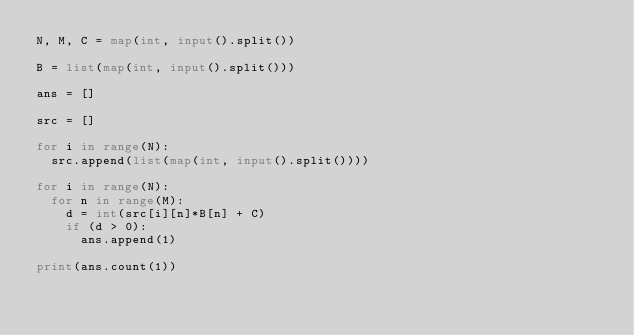Convert code to text. <code><loc_0><loc_0><loc_500><loc_500><_Python_>N, M, C = map(int, input().split())
 
B = list(map(int, input().split()))
 
ans = []
 
src = []
 
for i in range(N):
  src.append(list(map(int, input().split())))
  
for i in range(N):
  for n in range(M):
    d = int(src[i][n]*B[n] + C)
    if (d > 0):
      ans.append(1)

print(ans.count(1))</code> 